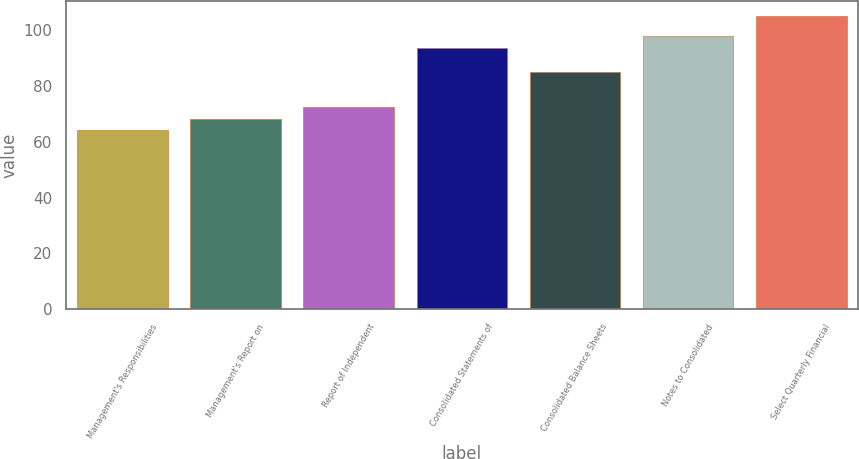<chart> <loc_0><loc_0><loc_500><loc_500><bar_chart><fcel>Management's Responsibilities<fcel>Management's Report on<fcel>Report of Independent<fcel>Consolidated Statements of<fcel>Consolidated Balance Sheets<fcel>Notes to Consolidated<fcel>Select Quarterly Financial<nl><fcel>64<fcel>68.2<fcel>72.4<fcel>93.4<fcel>85<fcel>97.6<fcel>105<nl></chart> 